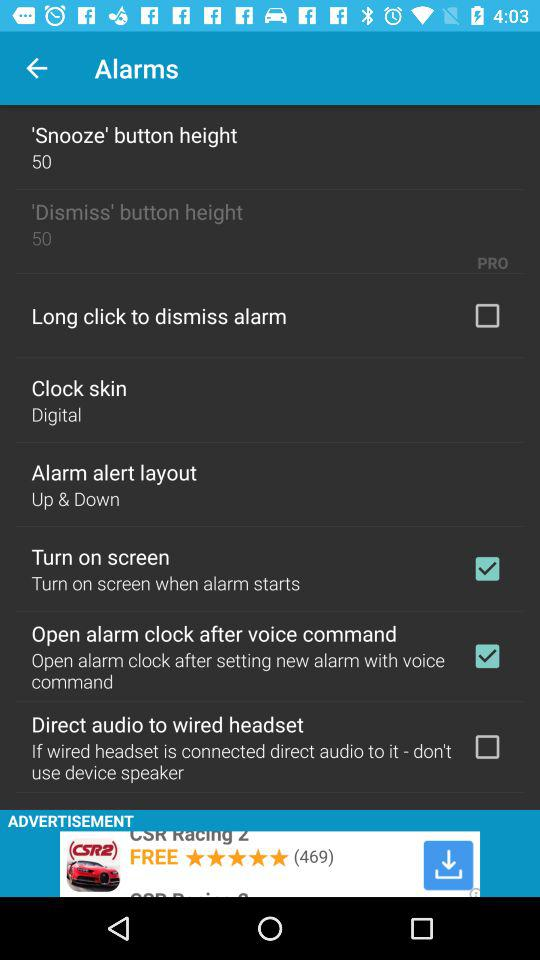What is the 'Snooze' button height? The 'Snooze' button height is 50. 